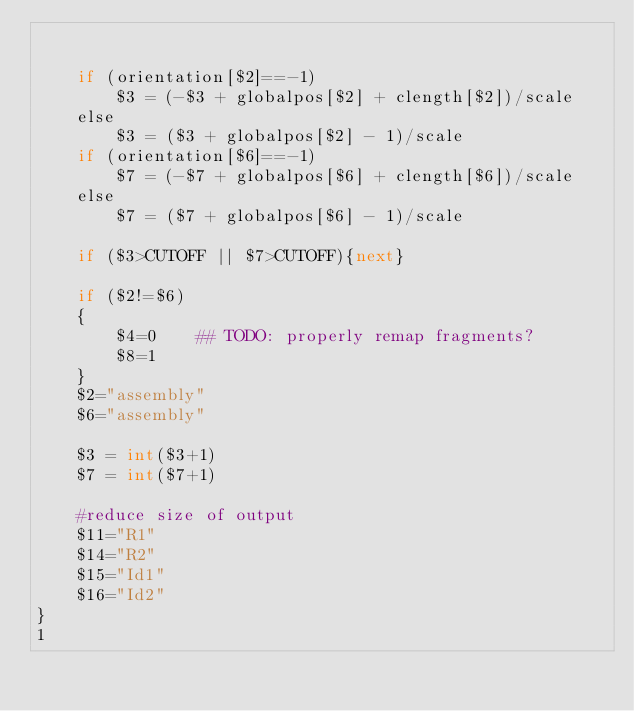Convert code to text. <code><loc_0><loc_0><loc_500><loc_500><_Awk_>

	if (orientation[$2]==-1)
		$3 = (-$3 + globalpos[$2] + clength[$2])/scale
	else
		$3 = ($3 + globalpos[$2] - 1)/scale
	if (orientation[$6]==-1)
		$7 = (-$7 + globalpos[$6] + clength[$6])/scale
	else
		$7 = ($7 + globalpos[$6] - 1)/scale
		
	if ($3>CUTOFF || $7>CUTOFF){next}
	
	if ($2!=$6)
	{
		$4=0	## TODO: properly remap fragments?
		$8=1
	}
	$2="assembly"
	$6="assembly"

	$3 = int($3+1)
	$7 = int($7+1)

	#reduce size of output
	$11="R1"
	$14="R2"
	$15="Id1"
	$16="Id2"
}
1
</code> 